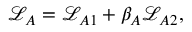<formula> <loc_0><loc_0><loc_500><loc_500>\begin{array} { r } { \mathcal { L } _ { A } = \mathcal { L } _ { A 1 } + \beta _ { A } \mathcal { L } _ { A 2 } , } \end{array}</formula> 